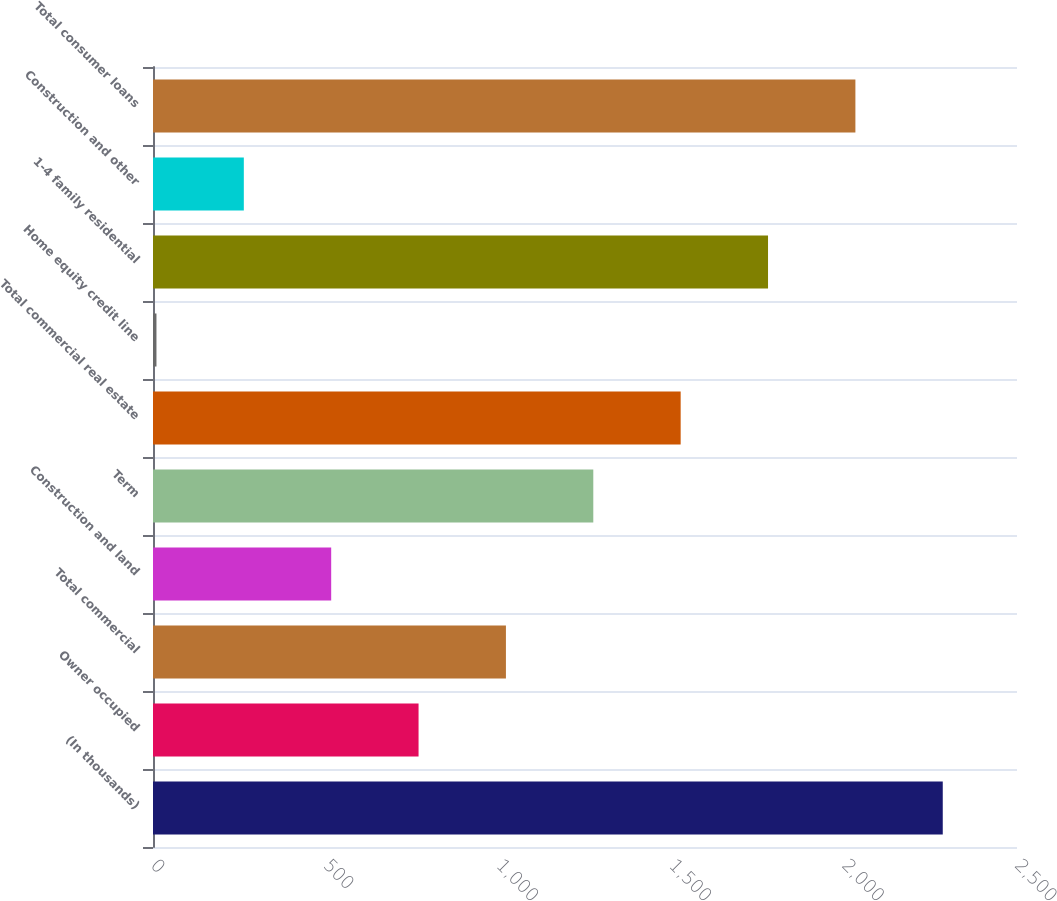<chart> <loc_0><loc_0><loc_500><loc_500><bar_chart><fcel>(In thousands)<fcel>Owner occupied<fcel>Total commercial<fcel>Construction and land<fcel>Term<fcel>Total commercial real estate<fcel>Home equity credit line<fcel>1-4 family residential<fcel>Construction and other<fcel>Total consumer loans<nl><fcel>2285.2<fcel>768.4<fcel>1021.2<fcel>515.6<fcel>1274<fcel>1526.8<fcel>10<fcel>1779.6<fcel>262.8<fcel>2032.4<nl></chart> 